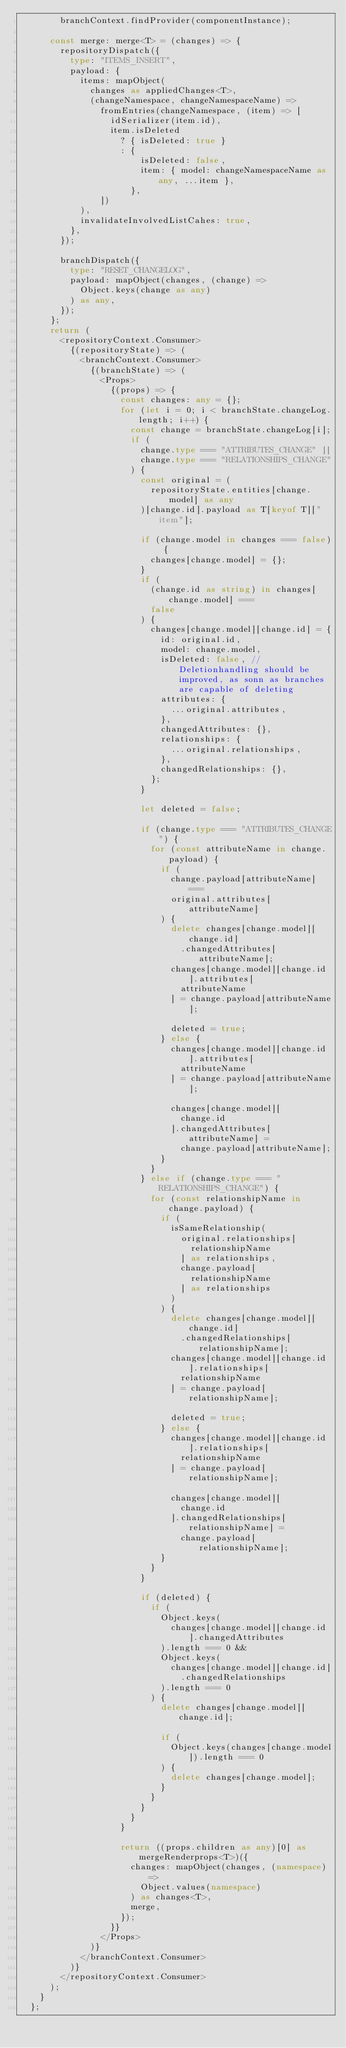Convert code to text. <code><loc_0><loc_0><loc_500><loc_500><_TypeScript_>        branchContext.findProvider(componentInstance);

      const merge: merge<T> = (changes) => {
        repositoryDispatch({
          type: "ITEMS_INSERT",
          payload: {
            items: mapObject(
              changes as appliedChanges<T>,
              (changeNamespace, changeNamespaceName) =>
                fromEntries(changeNamespace, (item) => [
                  idSerializer(item.id),
                  item.isDeleted
                    ? { isDeleted: true }
                    : {
                        isDeleted: false,
                        item: { model: changeNamespaceName as any, ...item },
                      },
                ])
            ),
            invalidateInvolvedListCahes: true,
          },
        });

        branchDispatch({
          type: "RESET_CHANGELOG",
          payload: mapObject(changes, (change) =>
            Object.keys(change as any)
          ) as any,
        });
      };
      return (
        <repositoryContext.Consumer>
          {(repositoryState) => (
            <branchContext.Consumer>
              {(branchState) => (
                <Props>
                  {(props) => {
                    const changes: any = {};
                    for (let i = 0; i < branchState.changeLog.length; i++) {
                      const change = branchState.changeLog[i];
                      if (
                        change.type === "ATTRIBUTES_CHANGE" ||
                        change.type === "RELATIONSHIPS_CHANGE"
                      ) {
                        const original = (
                          repositoryState.entities[change.model] as any
                        )[change.id].payload as T[keyof T]["item"];

                        if (change.model in changes === false) {
                          changes[change.model] = {};
                        }
                        if (
                          (change.id as string) in changes[change.model] ===
                          false
                        ) {
                          changes[change.model][change.id] = {
                            id: original.id,
                            model: change.model,
                            isDeleted: false, // Deletionhandling should be improved, as sonn as branches are capable of deleting
                            attributes: {
                              ...original.attributes,
                            },
                            changedAttributes: {},
                            relationships: {
                              ...original.relationships,
                            },
                            changedRelationships: {},
                          };
                        }

                        let deleted = false;

                        if (change.type === "ATTRIBUTES_CHANGE") {
                          for (const attributeName in change.payload) {
                            if (
                              change.payload[attributeName] ===
                              original.attributes[attributeName]
                            ) {
                              delete changes[change.model][change.id]
                                .changedAttributes[attributeName];
                              changes[change.model][change.id].attributes[
                                attributeName
                              ] = change.payload[attributeName];

                              deleted = true;
                            } else {
                              changes[change.model][change.id].attributes[
                                attributeName
                              ] = change.payload[attributeName];

                              changes[change.model][
                                change.id
                              ].changedAttributes[attributeName] =
                                change.payload[attributeName];
                            }
                          }
                        } else if (change.type === "RELATIONSHIPS_CHANGE") {
                          for (const relationshipName in change.payload) {
                            if (
                              isSameRelationship(
                                original.relationships[
                                  relationshipName
                                ] as relationships,
                                change.payload[
                                  relationshipName
                                ] as relationships
                              )
                            ) {
                              delete changes[change.model][change.id]
                                .changedRelationships[relationshipName];
                              changes[change.model][change.id].relationships[
                                relationshipName
                              ] = change.payload[relationshipName];

                              deleted = true;
                            } else {
                              changes[change.model][change.id].relationships[
                                relationshipName
                              ] = change.payload[relationshipName];

                              changes[change.model][
                                change.id
                              ].changedRelationships[relationshipName] =
                                change.payload[relationshipName];
                            }
                          }
                        }

                        if (deleted) {
                          if (
                            Object.keys(
                              changes[change.model][change.id].changedAttributes
                            ).length === 0 &&
                            Object.keys(
                              changes[change.model][change.id]
                                .changedRelationships
                            ).length === 0
                          ) {
                            delete changes[change.model][change.id];

                            if (
                              Object.keys(changes[change.model]).length === 0
                            ) {
                              delete changes[change.model];
                            }
                          }
                        }
                      }
                    }

                    return ((props.children as any)[0] as mergeRenderprops<T>)({
                      changes: mapObject(changes, (namespace) =>
                        Object.values(namespace)
                      ) as changes<T>,
                      merge,
                    });
                  }}
                </Props>
              )}
            </branchContext.Consumer>
          )}
        </repositoryContext.Consumer>
      );
    }
  };
</code> 